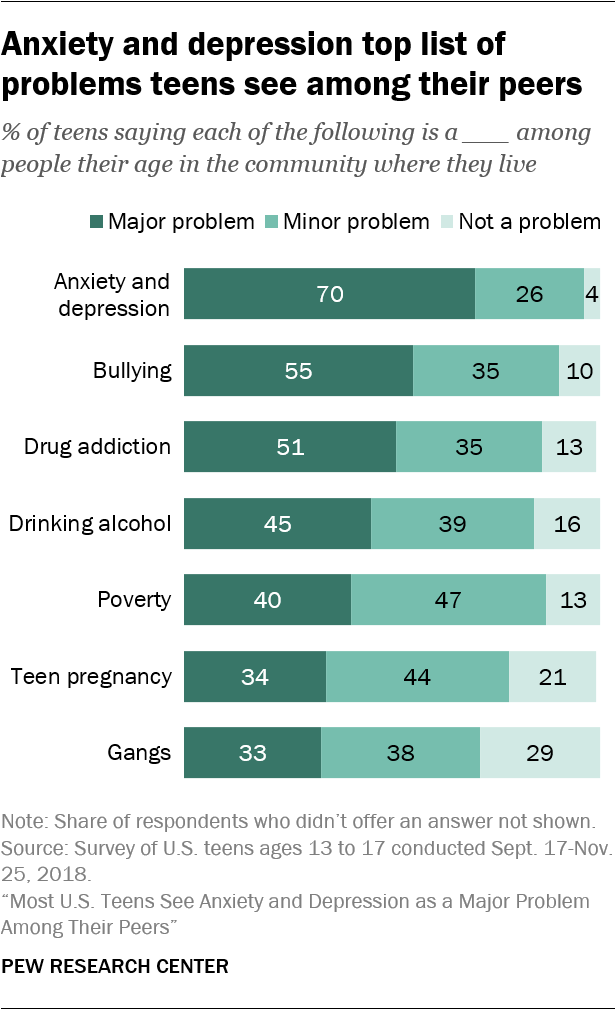Indicate a few pertinent items in this graphic. The value of the "Not a problem" opinion for the "Bullying" category is 10. The median of gangs bars is not greater than the median of poverty bars, according to the data presented. 